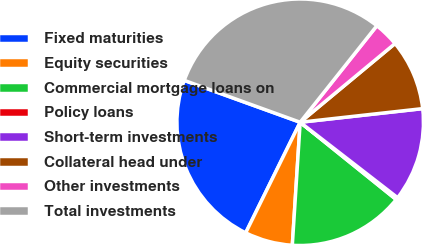<chart> <loc_0><loc_0><loc_500><loc_500><pie_chart><fcel>Fixed maturities<fcel>Equity securities<fcel>Commercial mortgage loans on<fcel>Policy loans<fcel>Short-term investments<fcel>Collateral head under<fcel>Other investments<fcel>Total investments<nl><fcel>23.23%<fcel>6.27%<fcel>15.23%<fcel>0.3%<fcel>12.25%<fcel>9.26%<fcel>3.29%<fcel>30.17%<nl></chart> 